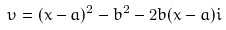<formula> <loc_0><loc_0><loc_500><loc_500>\upsilon = ( x - a ) ^ { 2 } - b ^ { 2 } - 2 b ( x - a ) i</formula> 